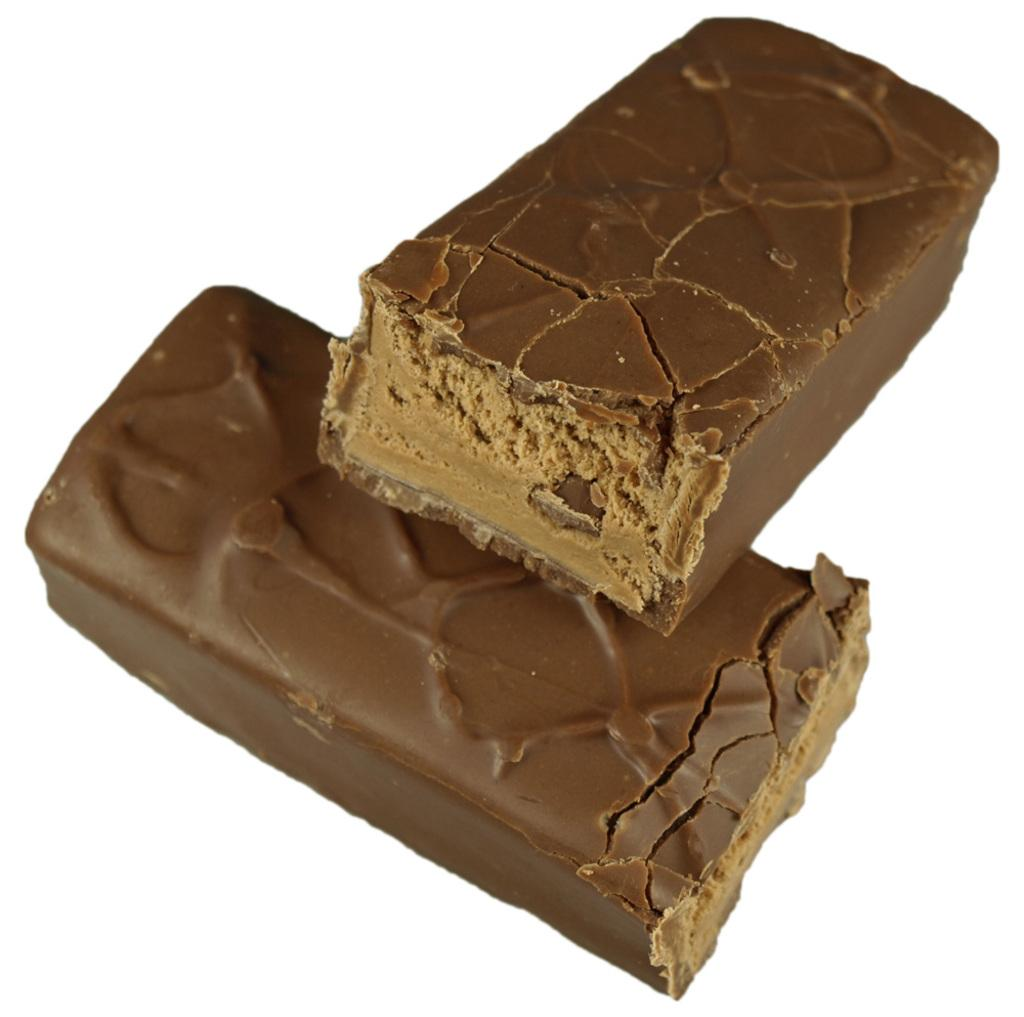What type of food is present in the image? There are chocolates in the image. What color is the background of the image? The background of the image is white. What type of authority figure can be seen in the image? There is no authority figure present in the image; it only features chocolates and a white background. 